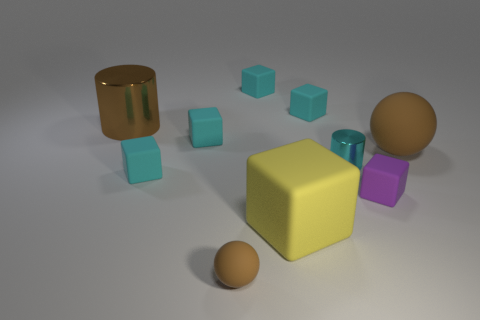Subtract all tiny matte blocks. How many blocks are left? 1 Subtract all yellow blocks. How many blocks are left? 5 Subtract all cubes. How many objects are left? 4 Subtract 1 cylinders. How many cylinders are left? 1 Subtract all blue cylinders. Subtract all purple blocks. How many cylinders are left? 2 Subtract all red spheres. How many blue cylinders are left? 0 Subtract all large brown matte objects. Subtract all purple things. How many objects are left? 8 Add 7 small purple blocks. How many small purple blocks are left? 8 Add 1 big yellow objects. How many big yellow objects exist? 2 Subtract 0 brown blocks. How many objects are left? 10 